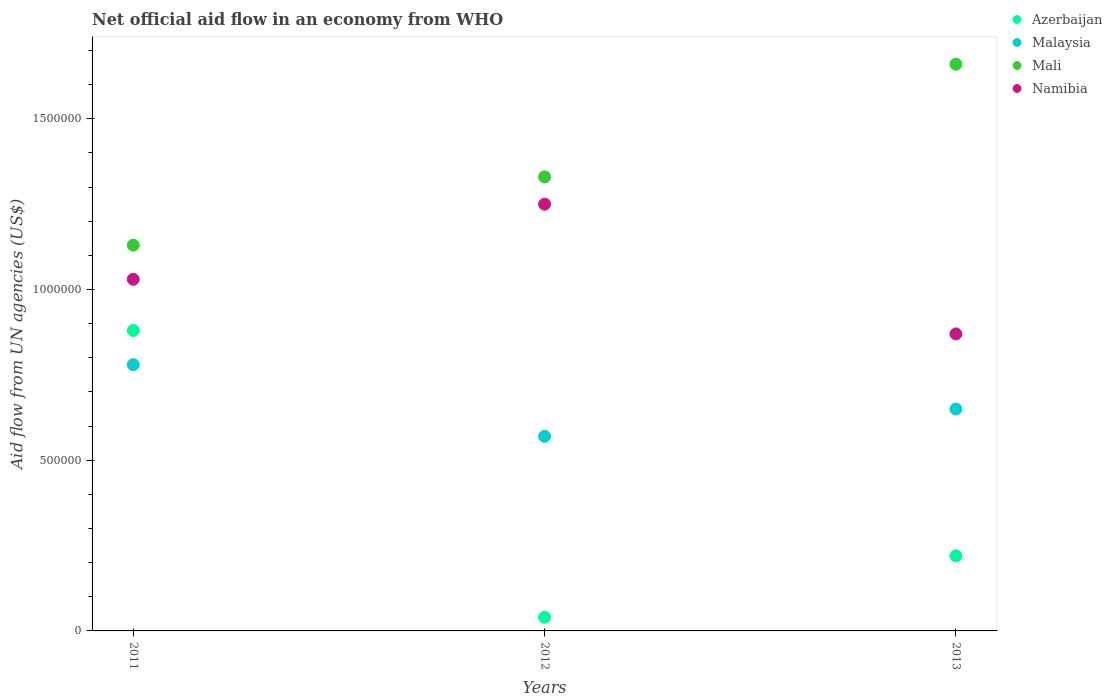Is the number of dotlines equal to the number of legend labels?
Ensure brevity in your answer.  Yes. What is the net official aid flow in Malaysia in 2011?
Your answer should be very brief. 7.80e+05. Across all years, what is the maximum net official aid flow in Azerbaijan?
Your answer should be compact. 8.80e+05. Across all years, what is the minimum net official aid flow in Namibia?
Keep it short and to the point. 8.70e+05. In which year was the net official aid flow in Mali maximum?
Offer a terse response. 2013. In which year was the net official aid flow in Malaysia minimum?
Keep it short and to the point. 2012. What is the total net official aid flow in Namibia in the graph?
Provide a succinct answer. 3.15e+06. What is the average net official aid flow in Mali per year?
Provide a short and direct response. 1.37e+06. In the year 2012, what is the difference between the net official aid flow in Namibia and net official aid flow in Azerbaijan?
Offer a very short reply. 1.21e+06. What is the difference between the highest and the lowest net official aid flow in Malaysia?
Offer a very short reply. 2.10e+05. Is it the case that in every year, the sum of the net official aid flow in Mali and net official aid flow in Namibia  is greater than the sum of net official aid flow in Malaysia and net official aid flow in Azerbaijan?
Give a very brief answer. Yes. Is it the case that in every year, the sum of the net official aid flow in Azerbaijan and net official aid flow in Namibia  is greater than the net official aid flow in Malaysia?
Make the answer very short. Yes. Does the net official aid flow in Malaysia monotonically increase over the years?
Keep it short and to the point. No. How many dotlines are there?
Make the answer very short. 4. Where does the legend appear in the graph?
Offer a very short reply. Top right. What is the title of the graph?
Keep it short and to the point. Net official aid flow in an economy from WHO. Does "Denmark" appear as one of the legend labels in the graph?
Offer a terse response. No. What is the label or title of the Y-axis?
Offer a very short reply. Aid flow from UN agencies (US$). What is the Aid flow from UN agencies (US$) in Azerbaijan in 2011?
Offer a very short reply. 8.80e+05. What is the Aid flow from UN agencies (US$) in Malaysia in 2011?
Your answer should be very brief. 7.80e+05. What is the Aid flow from UN agencies (US$) of Mali in 2011?
Offer a very short reply. 1.13e+06. What is the Aid flow from UN agencies (US$) of Namibia in 2011?
Ensure brevity in your answer.  1.03e+06. What is the Aid flow from UN agencies (US$) of Malaysia in 2012?
Keep it short and to the point. 5.70e+05. What is the Aid flow from UN agencies (US$) of Mali in 2012?
Your answer should be compact. 1.33e+06. What is the Aid flow from UN agencies (US$) of Namibia in 2012?
Offer a terse response. 1.25e+06. What is the Aid flow from UN agencies (US$) of Malaysia in 2013?
Provide a short and direct response. 6.50e+05. What is the Aid flow from UN agencies (US$) in Mali in 2013?
Give a very brief answer. 1.66e+06. What is the Aid flow from UN agencies (US$) in Namibia in 2013?
Ensure brevity in your answer.  8.70e+05. Across all years, what is the maximum Aid flow from UN agencies (US$) in Azerbaijan?
Provide a succinct answer. 8.80e+05. Across all years, what is the maximum Aid flow from UN agencies (US$) of Malaysia?
Offer a terse response. 7.80e+05. Across all years, what is the maximum Aid flow from UN agencies (US$) of Mali?
Offer a terse response. 1.66e+06. Across all years, what is the maximum Aid flow from UN agencies (US$) of Namibia?
Offer a terse response. 1.25e+06. Across all years, what is the minimum Aid flow from UN agencies (US$) in Azerbaijan?
Offer a terse response. 4.00e+04. Across all years, what is the minimum Aid flow from UN agencies (US$) in Malaysia?
Your answer should be compact. 5.70e+05. Across all years, what is the minimum Aid flow from UN agencies (US$) of Mali?
Give a very brief answer. 1.13e+06. Across all years, what is the minimum Aid flow from UN agencies (US$) in Namibia?
Your answer should be compact. 8.70e+05. What is the total Aid flow from UN agencies (US$) of Azerbaijan in the graph?
Give a very brief answer. 1.14e+06. What is the total Aid flow from UN agencies (US$) of Mali in the graph?
Your answer should be compact. 4.12e+06. What is the total Aid flow from UN agencies (US$) in Namibia in the graph?
Make the answer very short. 3.15e+06. What is the difference between the Aid flow from UN agencies (US$) in Azerbaijan in 2011 and that in 2012?
Provide a short and direct response. 8.40e+05. What is the difference between the Aid flow from UN agencies (US$) in Mali in 2011 and that in 2012?
Give a very brief answer. -2.00e+05. What is the difference between the Aid flow from UN agencies (US$) in Azerbaijan in 2011 and that in 2013?
Your answer should be very brief. 6.60e+05. What is the difference between the Aid flow from UN agencies (US$) of Mali in 2011 and that in 2013?
Offer a terse response. -5.30e+05. What is the difference between the Aid flow from UN agencies (US$) of Malaysia in 2012 and that in 2013?
Ensure brevity in your answer.  -8.00e+04. What is the difference between the Aid flow from UN agencies (US$) of Mali in 2012 and that in 2013?
Make the answer very short. -3.30e+05. What is the difference between the Aid flow from UN agencies (US$) of Azerbaijan in 2011 and the Aid flow from UN agencies (US$) of Mali in 2012?
Provide a short and direct response. -4.50e+05. What is the difference between the Aid flow from UN agencies (US$) of Azerbaijan in 2011 and the Aid flow from UN agencies (US$) of Namibia in 2012?
Make the answer very short. -3.70e+05. What is the difference between the Aid flow from UN agencies (US$) in Malaysia in 2011 and the Aid flow from UN agencies (US$) in Mali in 2012?
Provide a short and direct response. -5.50e+05. What is the difference between the Aid flow from UN agencies (US$) in Malaysia in 2011 and the Aid flow from UN agencies (US$) in Namibia in 2012?
Your answer should be compact. -4.70e+05. What is the difference between the Aid flow from UN agencies (US$) in Azerbaijan in 2011 and the Aid flow from UN agencies (US$) in Malaysia in 2013?
Keep it short and to the point. 2.30e+05. What is the difference between the Aid flow from UN agencies (US$) in Azerbaijan in 2011 and the Aid flow from UN agencies (US$) in Mali in 2013?
Provide a succinct answer. -7.80e+05. What is the difference between the Aid flow from UN agencies (US$) of Azerbaijan in 2011 and the Aid flow from UN agencies (US$) of Namibia in 2013?
Your answer should be very brief. 10000. What is the difference between the Aid flow from UN agencies (US$) of Malaysia in 2011 and the Aid flow from UN agencies (US$) of Mali in 2013?
Keep it short and to the point. -8.80e+05. What is the difference between the Aid flow from UN agencies (US$) in Malaysia in 2011 and the Aid flow from UN agencies (US$) in Namibia in 2013?
Ensure brevity in your answer.  -9.00e+04. What is the difference between the Aid flow from UN agencies (US$) in Mali in 2011 and the Aid flow from UN agencies (US$) in Namibia in 2013?
Give a very brief answer. 2.60e+05. What is the difference between the Aid flow from UN agencies (US$) of Azerbaijan in 2012 and the Aid flow from UN agencies (US$) of Malaysia in 2013?
Offer a very short reply. -6.10e+05. What is the difference between the Aid flow from UN agencies (US$) in Azerbaijan in 2012 and the Aid flow from UN agencies (US$) in Mali in 2013?
Your answer should be compact. -1.62e+06. What is the difference between the Aid flow from UN agencies (US$) in Azerbaijan in 2012 and the Aid flow from UN agencies (US$) in Namibia in 2013?
Your answer should be compact. -8.30e+05. What is the difference between the Aid flow from UN agencies (US$) of Malaysia in 2012 and the Aid flow from UN agencies (US$) of Mali in 2013?
Make the answer very short. -1.09e+06. What is the difference between the Aid flow from UN agencies (US$) in Mali in 2012 and the Aid flow from UN agencies (US$) in Namibia in 2013?
Provide a short and direct response. 4.60e+05. What is the average Aid flow from UN agencies (US$) in Azerbaijan per year?
Your response must be concise. 3.80e+05. What is the average Aid flow from UN agencies (US$) in Malaysia per year?
Provide a short and direct response. 6.67e+05. What is the average Aid flow from UN agencies (US$) in Mali per year?
Provide a succinct answer. 1.37e+06. What is the average Aid flow from UN agencies (US$) in Namibia per year?
Your answer should be compact. 1.05e+06. In the year 2011, what is the difference between the Aid flow from UN agencies (US$) of Azerbaijan and Aid flow from UN agencies (US$) of Malaysia?
Your response must be concise. 1.00e+05. In the year 2011, what is the difference between the Aid flow from UN agencies (US$) of Azerbaijan and Aid flow from UN agencies (US$) of Mali?
Your answer should be compact. -2.50e+05. In the year 2011, what is the difference between the Aid flow from UN agencies (US$) in Malaysia and Aid flow from UN agencies (US$) in Mali?
Give a very brief answer. -3.50e+05. In the year 2011, what is the difference between the Aid flow from UN agencies (US$) in Malaysia and Aid flow from UN agencies (US$) in Namibia?
Provide a succinct answer. -2.50e+05. In the year 2012, what is the difference between the Aid flow from UN agencies (US$) in Azerbaijan and Aid flow from UN agencies (US$) in Malaysia?
Your response must be concise. -5.30e+05. In the year 2012, what is the difference between the Aid flow from UN agencies (US$) in Azerbaijan and Aid flow from UN agencies (US$) in Mali?
Your answer should be compact. -1.29e+06. In the year 2012, what is the difference between the Aid flow from UN agencies (US$) in Azerbaijan and Aid flow from UN agencies (US$) in Namibia?
Ensure brevity in your answer.  -1.21e+06. In the year 2012, what is the difference between the Aid flow from UN agencies (US$) in Malaysia and Aid flow from UN agencies (US$) in Mali?
Provide a short and direct response. -7.60e+05. In the year 2012, what is the difference between the Aid flow from UN agencies (US$) in Malaysia and Aid flow from UN agencies (US$) in Namibia?
Your response must be concise. -6.80e+05. In the year 2013, what is the difference between the Aid flow from UN agencies (US$) in Azerbaijan and Aid flow from UN agencies (US$) in Malaysia?
Your answer should be compact. -4.30e+05. In the year 2013, what is the difference between the Aid flow from UN agencies (US$) of Azerbaijan and Aid flow from UN agencies (US$) of Mali?
Your answer should be very brief. -1.44e+06. In the year 2013, what is the difference between the Aid flow from UN agencies (US$) in Azerbaijan and Aid flow from UN agencies (US$) in Namibia?
Offer a very short reply. -6.50e+05. In the year 2013, what is the difference between the Aid flow from UN agencies (US$) of Malaysia and Aid flow from UN agencies (US$) of Mali?
Provide a succinct answer. -1.01e+06. In the year 2013, what is the difference between the Aid flow from UN agencies (US$) of Mali and Aid flow from UN agencies (US$) of Namibia?
Your answer should be compact. 7.90e+05. What is the ratio of the Aid flow from UN agencies (US$) of Malaysia in 2011 to that in 2012?
Give a very brief answer. 1.37. What is the ratio of the Aid flow from UN agencies (US$) of Mali in 2011 to that in 2012?
Offer a very short reply. 0.85. What is the ratio of the Aid flow from UN agencies (US$) of Namibia in 2011 to that in 2012?
Make the answer very short. 0.82. What is the ratio of the Aid flow from UN agencies (US$) in Azerbaijan in 2011 to that in 2013?
Provide a short and direct response. 4. What is the ratio of the Aid flow from UN agencies (US$) of Mali in 2011 to that in 2013?
Offer a terse response. 0.68. What is the ratio of the Aid flow from UN agencies (US$) in Namibia in 2011 to that in 2013?
Provide a succinct answer. 1.18. What is the ratio of the Aid flow from UN agencies (US$) of Azerbaijan in 2012 to that in 2013?
Ensure brevity in your answer.  0.18. What is the ratio of the Aid flow from UN agencies (US$) of Malaysia in 2012 to that in 2013?
Give a very brief answer. 0.88. What is the ratio of the Aid flow from UN agencies (US$) in Mali in 2012 to that in 2013?
Your answer should be very brief. 0.8. What is the ratio of the Aid flow from UN agencies (US$) in Namibia in 2012 to that in 2013?
Keep it short and to the point. 1.44. What is the difference between the highest and the second highest Aid flow from UN agencies (US$) of Azerbaijan?
Your answer should be compact. 6.60e+05. What is the difference between the highest and the second highest Aid flow from UN agencies (US$) in Mali?
Your answer should be very brief. 3.30e+05. What is the difference between the highest and the second highest Aid flow from UN agencies (US$) in Namibia?
Offer a terse response. 2.20e+05. What is the difference between the highest and the lowest Aid flow from UN agencies (US$) in Azerbaijan?
Offer a terse response. 8.40e+05. What is the difference between the highest and the lowest Aid flow from UN agencies (US$) of Malaysia?
Offer a terse response. 2.10e+05. What is the difference between the highest and the lowest Aid flow from UN agencies (US$) in Mali?
Ensure brevity in your answer.  5.30e+05. What is the difference between the highest and the lowest Aid flow from UN agencies (US$) of Namibia?
Your answer should be very brief. 3.80e+05. 